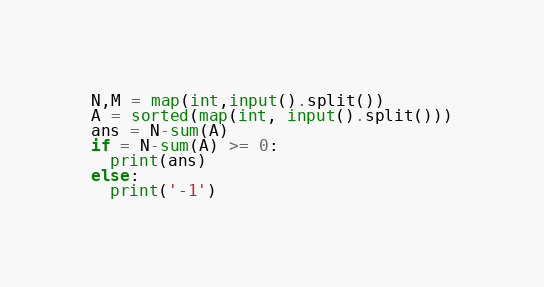<code> <loc_0><loc_0><loc_500><loc_500><_Python_>N,M = map(int,input().split())
A = sorted(map(int, input().split()))
ans = N-sum(A)
if = N-sum(A) >= 0:
  print(ans)
else:
  print('-1')</code> 